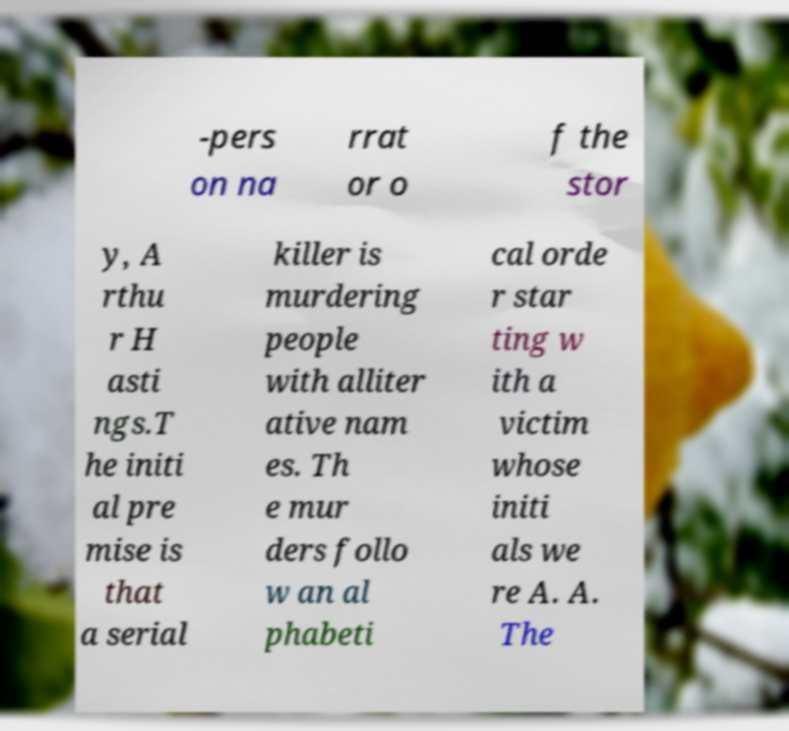Could you extract and type out the text from this image? -pers on na rrat or o f the stor y, A rthu r H asti ngs.T he initi al pre mise is that a serial killer is murdering people with alliter ative nam es. Th e mur ders follo w an al phabeti cal orde r star ting w ith a victim whose initi als we re A. A. The 